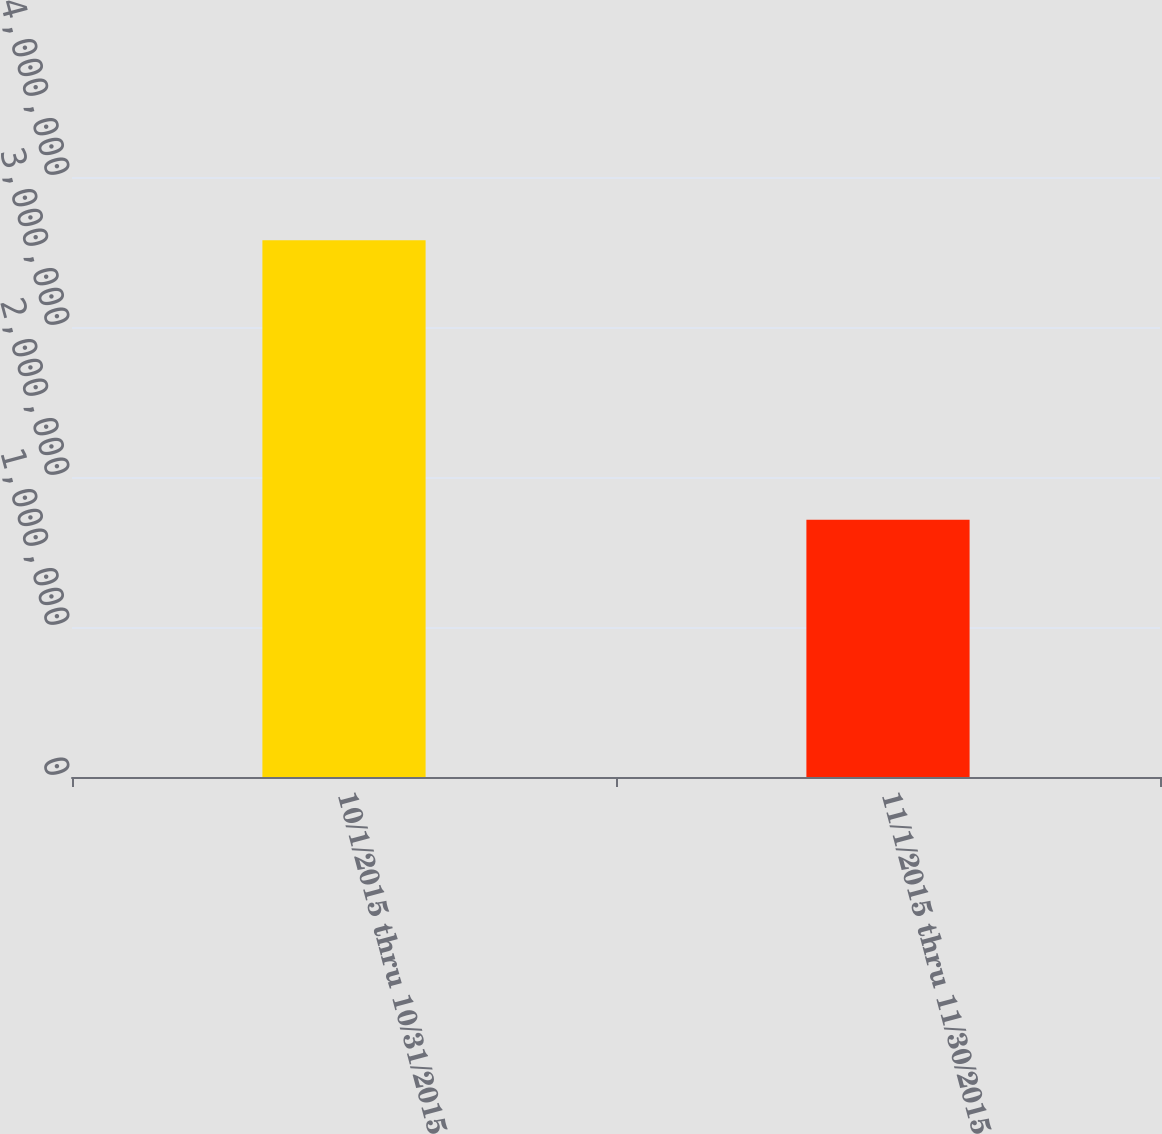Convert chart to OTSL. <chart><loc_0><loc_0><loc_500><loc_500><bar_chart><fcel>10/1/2015 thru 10/31/2015<fcel>11/1/2015 thru 11/30/2015<nl><fcel>3.57776e+06<fcel>1.7146e+06<nl></chart> 